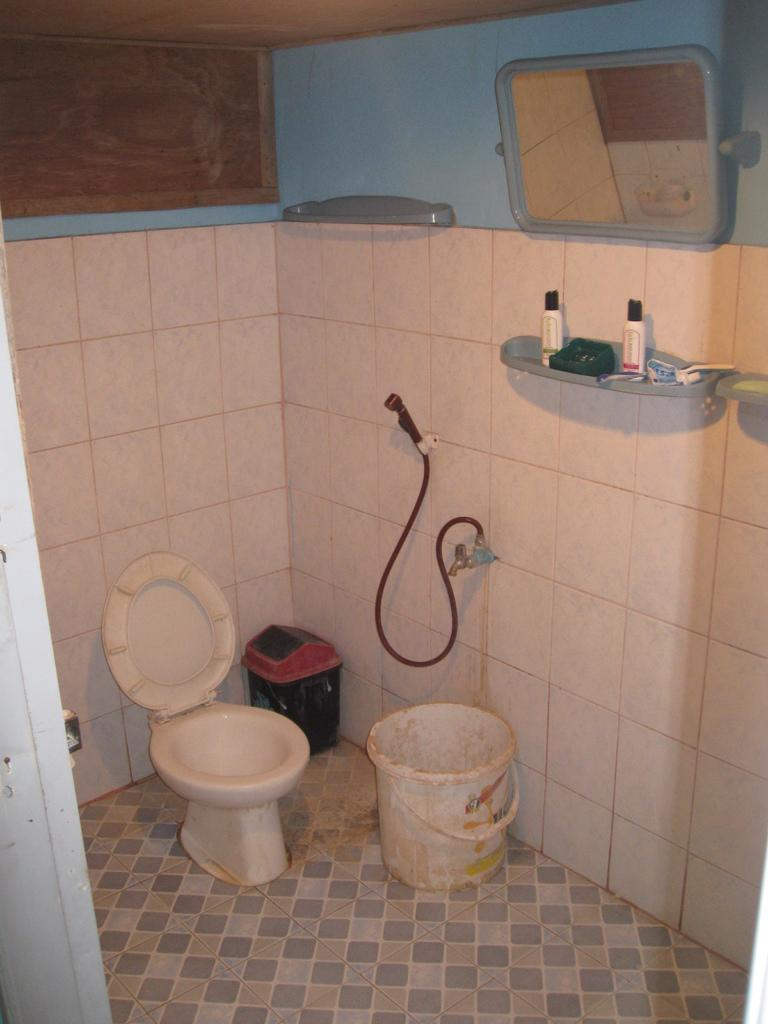What type of room is depicted in the image? The image is of a washroom. What is one of the main fixtures in a washroom? There is a commode in the washroom. What is another item that might be found in a washroom? There is a bucket in the washroom. What is used for disposing of waste in the washroom? There is a bin in the washroom. What is used for supplying water in the washroom? There is a pipe in the washroom. How is water controlled in the washroom? There is a tap in the washroom. What might be used for storing liquids in the washroom? There are bottles in the washroom. What is used for personal grooming in the washroom? There is a mirror in the washroom. What is the surface on which people stand in the washroom? The washroom has a floor. What encloses the space of the washroom? There are walls in the washroom. Where is the kettle located in the washroom? There is no kettle present in the washroom. Can you find a map in the washroom? There is no map present in the washroom. 